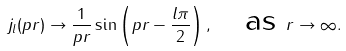Convert formula to latex. <formula><loc_0><loc_0><loc_500><loc_500>j _ { l } ( p r ) \rightarrow \frac { 1 } { p r } \sin \left ( p r - \frac { l \pi } { 2 } \right ) , \quad \text {as } r \rightarrow \infty .</formula> 